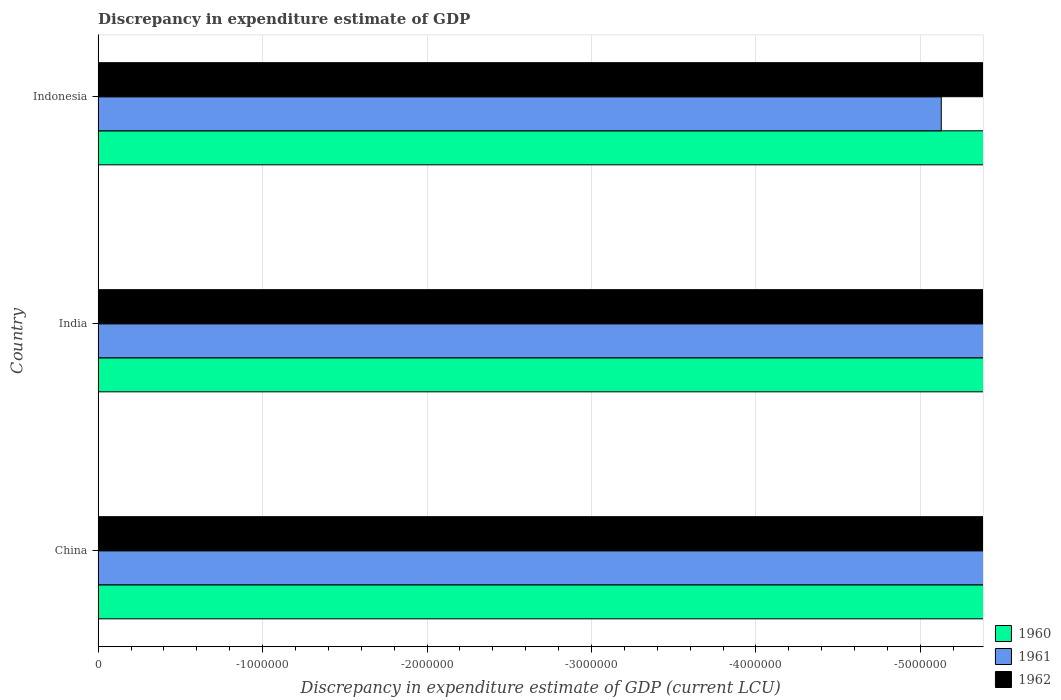How many different coloured bars are there?
Your answer should be compact. 0. Are the number of bars per tick equal to the number of legend labels?
Give a very brief answer. No. Are the number of bars on each tick of the Y-axis equal?
Your answer should be compact. Yes. What is the label of the 2nd group of bars from the top?
Offer a very short reply. India. In how many cases, is the number of bars for a given country not equal to the number of legend labels?
Offer a terse response. 3. Across all countries, what is the minimum discrepancy in expenditure estimate of GDP in 1961?
Your answer should be very brief. 0. What is the total discrepancy in expenditure estimate of GDP in 1961 in the graph?
Offer a very short reply. 0. What is the difference between the discrepancy in expenditure estimate of GDP in 1961 in India and the discrepancy in expenditure estimate of GDP in 1960 in Indonesia?
Offer a very short reply. 0. What is the average discrepancy in expenditure estimate of GDP in 1961 per country?
Offer a very short reply. 0. In how many countries, is the discrepancy in expenditure estimate of GDP in 1961 greater than the average discrepancy in expenditure estimate of GDP in 1961 taken over all countries?
Offer a very short reply. 0. Is it the case that in every country, the sum of the discrepancy in expenditure estimate of GDP in 1960 and discrepancy in expenditure estimate of GDP in 1962 is greater than the discrepancy in expenditure estimate of GDP in 1961?
Provide a short and direct response. No. How many countries are there in the graph?
Ensure brevity in your answer.  3. What is the difference between two consecutive major ticks on the X-axis?
Your answer should be very brief. 1.00e+06. Are the values on the major ticks of X-axis written in scientific E-notation?
Your answer should be very brief. No. Where does the legend appear in the graph?
Make the answer very short. Bottom right. What is the title of the graph?
Offer a terse response. Discrepancy in expenditure estimate of GDP. What is the label or title of the X-axis?
Give a very brief answer. Discrepancy in expenditure estimate of GDP (current LCU). What is the label or title of the Y-axis?
Your answer should be very brief. Country. What is the Discrepancy in expenditure estimate of GDP (current LCU) in 1962 in China?
Make the answer very short. 0. What is the Discrepancy in expenditure estimate of GDP (current LCU) of 1961 in Indonesia?
Your answer should be very brief. 0. What is the Discrepancy in expenditure estimate of GDP (current LCU) in 1962 in Indonesia?
Provide a short and direct response. 0. What is the average Discrepancy in expenditure estimate of GDP (current LCU) in 1960 per country?
Offer a terse response. 0. What is the average Discrepancy in expenditure estimate of GDP (current LCU) of 1961 per country?
Your answer should be compact. 0. What is the average Discrepancy in expenditure estimate of GDP (current LCU) in 1962 per country?
Make the answer very short. 0. 